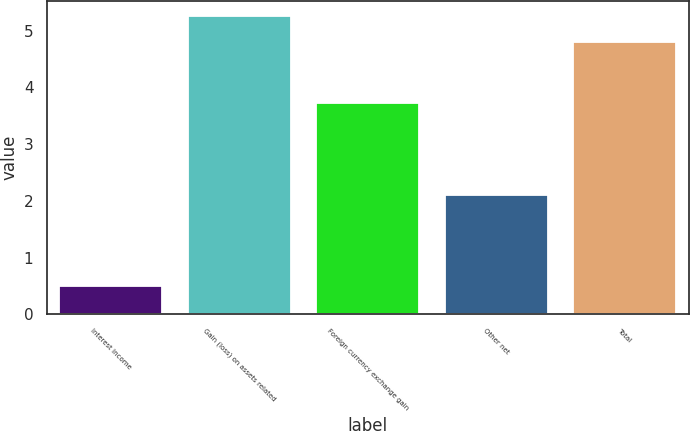Convert chart. <chart><loc_0><loc_0><loc_500><loc_500><bar_chart><fcel>Interest income<fcel>Gain (loss) on assets related<fcel>Foreign currency exchange gain<fcel>Other net<fcel>Total<nl><fcel>0.5<fcel>5.26<fcel>3.72<fcel>2.1<fcel>4.8<nl></chart> 